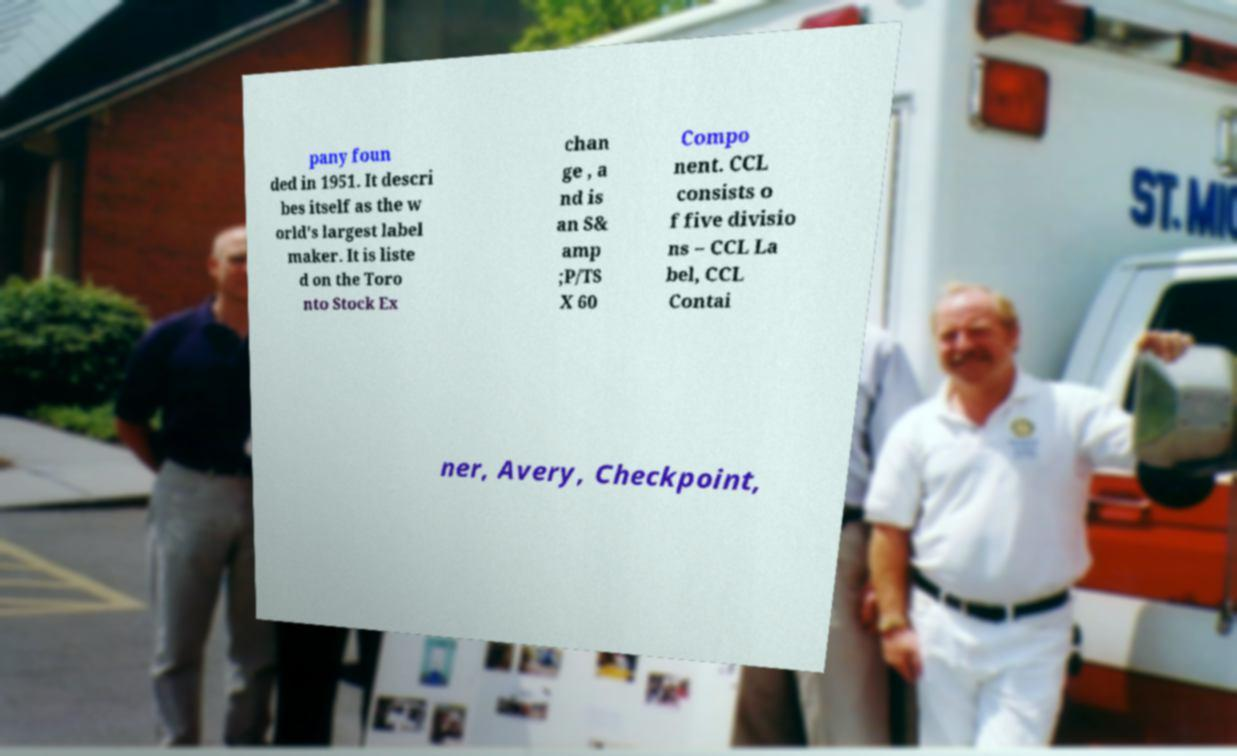For documentation purposes, I need the text within this image transcribed. Could you provide that? pany foun ded in 1951. It descri bes itself as the w orld's largest label maker. It is liste d on the Toro nto Stock Ex chan ge , a nd is an S& amp ;P/TS X 60 Compo nent. CCL consists o f five divisio ns – CCL La bel, CCL Contai ner, Avery, Checkpoint, 